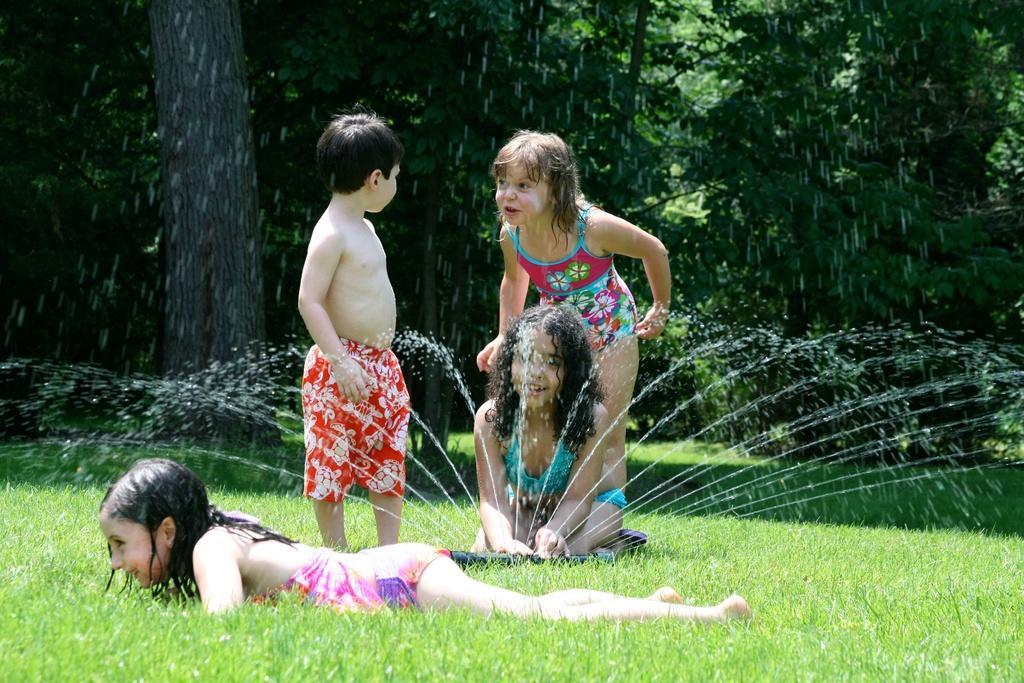In one or two sentences, can you explain what this image depicts? In the foreground I can see four kids on grass, water and an object. In the background I can see trees. This image is taken may be in a park during a day. 